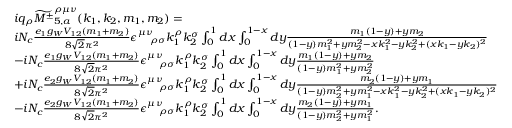Convert formula to latex. <formula><loc_0><loc_0><loc_500><loc_500>\begin{array} { r l } & { i q _ { \rho } \widetilde { { M ^ { \pm } } } _ { 5 , a } ^ { \rho \mu \nu } ( k _ { 1 } , k _ { 2 } , m _ { 1 } , m _ { 2 } ) = } \\ & { i N _ { c } \frac { e _ { 1 } g _ { W } V _ { 1 2 } ( m _ { 1 } + m _ { 2 } ) } { 8 \sqrt { 2 } \pi ^ { 2 } } \epsilon _ { \quad \rho \sigma } ^ { \mu \nu } k _ { 1 } ^ { \rho } k _ { 2 } ^ { \sigma } \int _ { 0 } ^ { 1 } d x \int _ { 0 } ^ { 1 - x } d y \frac { m _ { 1 } ( 1 - y ) + y m _ { 2 } } { ( 1 - y ) m _ { 1 } ^ { 2 } + y m _ { 2 } ^ { 2 } - x k _ { 1 } ^ { 2 } - y k _ { 2 } ^ { 2 } + ( x k _ { 1 } - y k _ { 2 } ) ^ { 2 } } } \\ & { - i N _ { c } \frac { e _ { 1 } g _ { W } V _ { 1 2 } ( m _ { 1 } + m _ { 2 } ) } { 8 \sqrt { 2 } \pi ^ { 2 } } \epsilon _ { \quad \rho \sigma } ^ { \mu \nu } k _ { 1 } ^ { \rho } k _ { 2 } ^ { \sigma } \int _ { 0 } ^ { 1 } d x \int _ { 0 } ^ { 1 - x } d y \frac { m _ { 1 } ( 1 - y ) + y m _ { 2 } } { ( 1 - y ) m _ { 1 } ^ { 2 } + y m _ { 2 } ^ { 2 } } } \\ & { + i N _ { c } \frac { e _ { 2 } g _ { W } V _ { 1 2 } ( m _ { 1 } + m _ { 2 } ) } { 8 \sqrt { 2 } \pi ^ { 2 } } \epsilon _ { \quad \rho \sigma } ^ { \mu \nu } k _ { 1 } ^ { \rho } k _ { 2 } ^ { \sigma } \int _ { 0 } ^ { 1 } d x \int _ { 0 } ^ { 1 - x } d y \frac { m _ { 2 } ( 1 - y ) + y m _ { 1 } } { ( 1 - y ) m _ { 2 } ^ { 2 } + y m _ { 1 } ^ { 2 } - x k _ { 1 } ^ { 2 } - y k _ { 2 } ^ { 2 } + ( x k _ { 1 } - y k _ { 2 } ) ^ { 2 } } } \\ & { - i N _ { c } \frac { e _ { 2 } g _ { W } V _ { 1 2 } ( m _ { 1 } + m _ { 2 } ) } { 8 \sqrt { 2 } \pi ^ { 2 } } \epsilon _ { \quad \rho \sigma } ^ { \mu \nu } k _ { 1 } ^ { \rho } k _ { 2 } ^ { \sigma } \int _ { 0 } ^ { 1 } d x \int _ { 0 } ^ { 1 - x } d y \frac { m _ { 2 } ( 1 - y ) + y m _ { 1 } } { ( 1 - y ) m _ { 2 } ^ { 2 } + y m _ { 1 } ^ { 2 } } . } \end{array}</formula> 